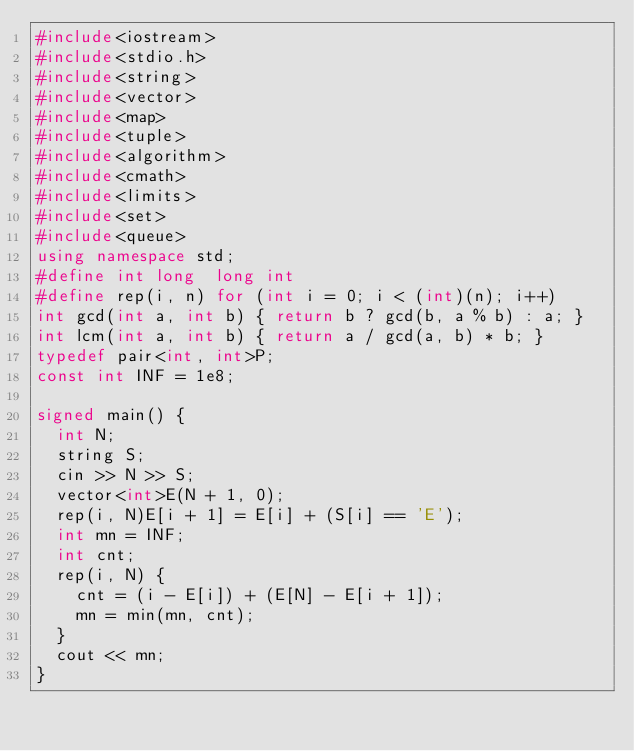Convert code to text. <code><loc_0><loc_0><loc_500><loc_500><_C++_>#include<iostream>
#include<stdio.h>
#include<string>
#include<vector>
#include<map>
#include<tuple>
#include<algorithm>
#include<cmath>
#include<limits>
#include<set>
#include<queue>
using namespace std;
#define int long  long int
#define rep(i, n) for (int i = 0; i < (int)(n); i++)
int gcd(int a, int b) { return b ? gcd(b, a % b) : a; }
int lcm(int a, int b) { return a / gcd(a, b) * b; }
typedef pair<int, int>P;
const int INF = 1e8;

signed main() {
	int N;
	string S;
	cin >> N >> S;
	vector<int>E(N + 1, 0);
	rep(i, N)E[i + 1] = E[i] + (S[i] == 'E');
	int mn = INF;
	int cnt;
	rep(i, N) {
		cnt = (i - E[i]) + (E[N] - E[i + 1]);
		mn = min(mn, cnt);
	}
	cout << mn;
}</code> 